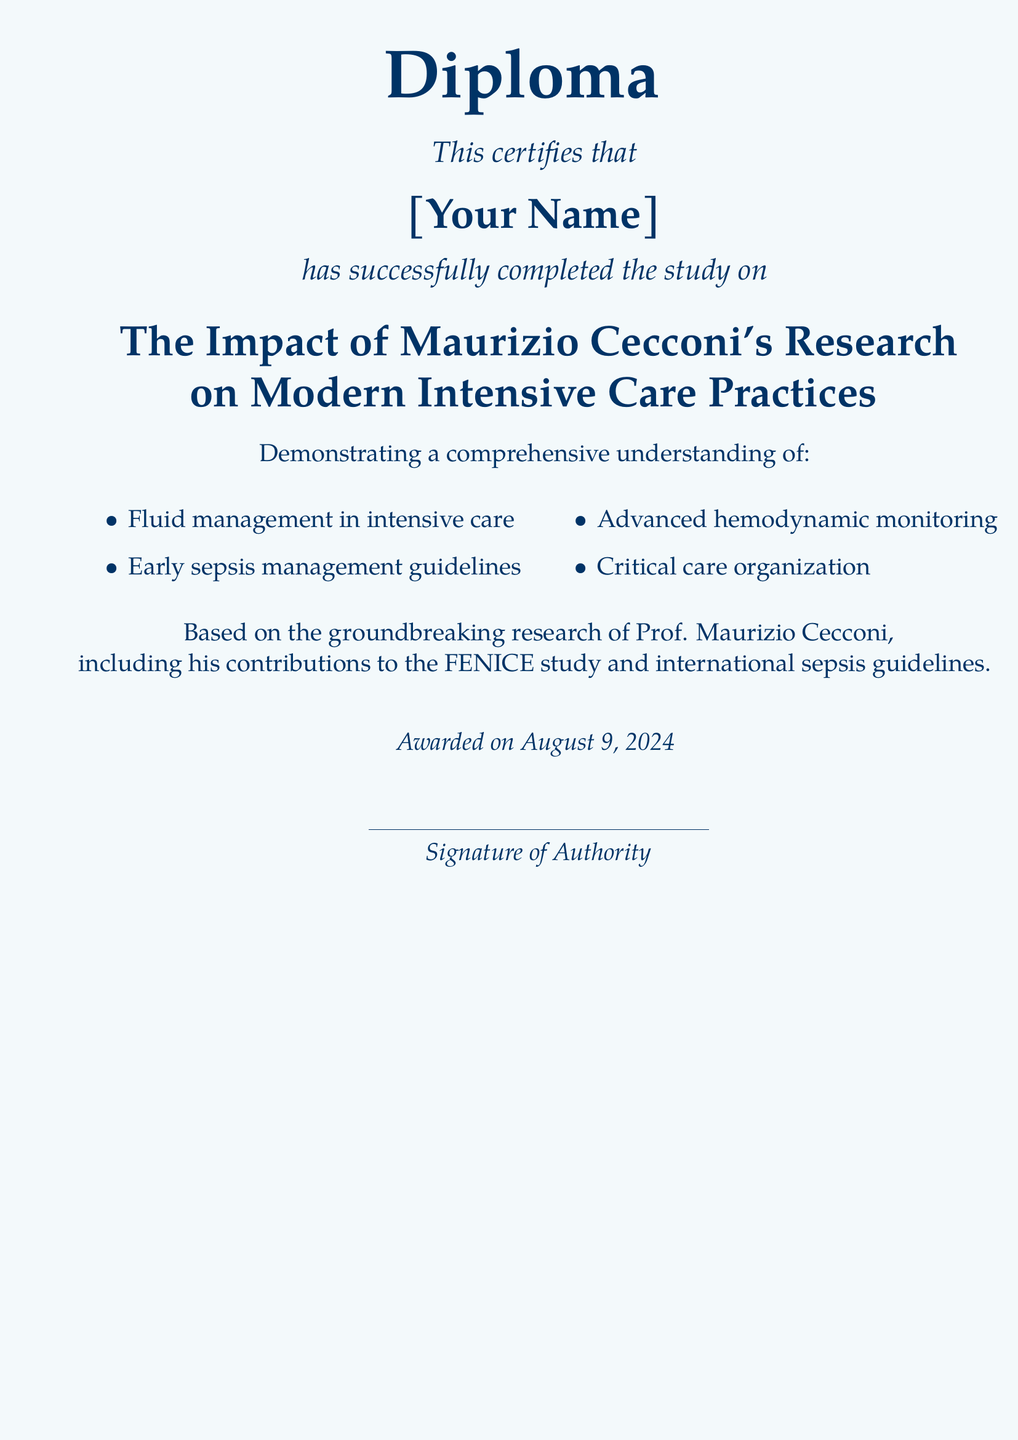What is the diploma about? The diploma certifies the completion of a study on Maurizio Cecconi's research impact on intensive care practices.
Answer: The Impact of Maurizio Cecconi's Research on Modern Intensive Care Practices Who is awarded the diploma? The diploma is awarded to the individual whose name is placed on it.
Answer: [Your Name] What field does the diploma focus on? The diploma focus is on the impact of research in a specific medical field.
Answer: Intensive care practices What is one of the key contributions of Prof. Maurizio Cecconi mentioned? It highlights specific efforts made by Prof. Cecconi in the field.
Answer: FENICE study How many key areas of understanding are listed? This refers to the number of specific topics of knowledge demonstrated in the study.
Answer: Four What kind of guidelines are mentioned in the diploma? This references a specific type of medical protocol addressed in the study.
Answer: Early sepsis management guidelines What is the date on the diploma? The date indicates when the diploma was awarded, which is dynamic and based on the current day.
Answer: today What is one of the advanced topics mentioned in the diploma? This question refers to a specific advanced medical practice identified in the document.
Answer: Advanced hemodynamic monitoring What does the diploma certify? This signifies what the document states about the individual's achievements.
Answer: Successful completion of the study 